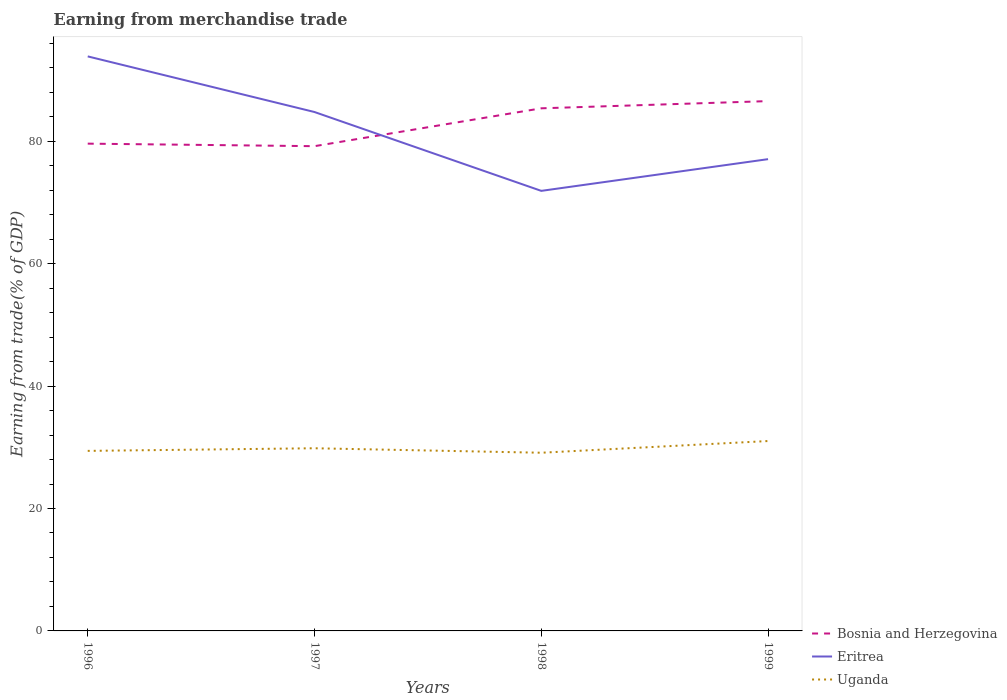How many different coloured lines are there?
Offer a very short reply. 3. Is the number of lines equal to the number of legend labels?
Offer a very short reply. Yes. Across all years, what is the maximum earnings from trade in Eritrea?
Provide a succinct answer. 71.9. What is the total earnings from trade in Bosnia and Herzegovina in the graph?
Your answer should be compact. -5.77. What is the difference between the highest and the second highest earnings from trade in Bosnia and Herzegovina?
Ensure brevity in your answer.  7.36. How many lines are there?
Your response must be concise. 3. How many years are there in the graph?
Offer a very short reply. 4. What is the difference between two consecutive major ticks on the Y-axis?
Provide a short and direct response. 20. Does the graph contain grids?
Provide a short and direct response. No. Where does the legend appear in the graph?
Make the answer very short. Bottom right. How many legend labels are there?
Make the answer very short. 3. How are the legend labels stacked?
Provide a succinct answer. Vertical. What is the title of the graph?
Your response must be concise. Earning from merchandise trade. Does "Congo (Republic)" appear as one of the legend labels in the graph?
Offer a very short reply. No. What is the label or title of the Y-axis?
Make the answer very short. Earning from trade(% of GDP). What is the Earning from trade(% of GDP) of Bosnia and Herzegovina in 1996?
Keep it short and to the point. 79.61. What is the Earning from trade(% of GDP) in Eritrea in 1996?
Offer a very short reply. 93.87. What is the Earning from trade(% of GDP) of Uganda in 1996?
Provide a short and direct response. 29.41. What is the Earning from trade(% of GDP) in Bosnia and Herzegovina in 1997?
Offer a very short reply. 79.2. What is the Earning from trade(% of GDP) of Eritrea in 1997?
Provide a short and direct response. 84.78. What is the Earning from trade(% of GDP) of Uganda in 1997?
Your answer should be compact. 29.84. What is the Earning from trade(% of GDP) of Bosnia and Herzegovina in 1998?
Keep it short and to the point. 85.38. What is the Earning from trade(% of GDP) in Eritrea in 1998?
Keep it short and to the point. 71.9. What is the Earning from trade(% of GDP) in Uganda in 1998?
Keep it short and to the point. 29.11. What is the Earning from trade(% of GDP) in Bosnia and Herzegovina in 1999?
Provide a succinct answer. 86.56. What is the Earning from trade(% of GDP) in Eritrea in 1999?
Offer a terse response. 77.08. What is the Earning from trade(% of GDP) of Uganda in 1999?
Ensure brevity in your answer.  31.02. Across all years, what is the maximum Earning from trade(% of GDP) in Bosnia and Herzegovina?
Give a very brief answer. 86.56. Across all years, what is the maximum Earning from trade(% of GDP) of Eritrea?
Keep it short and to the point. 93.87. Across all years, what is the maximum Earning from trade(% of GDP) in Uganda?
Your answer should be compact. 31.02. Across all years, what is the minimum Earning from trade(% of GDP) in Bosnia and Herzegovina?
Provide a short and direct response. 79.2. Across all years, what is the minimum Earning from trade(% of GDP) of Eritrea?
Ensure brevity in your answer.  71.9. Across all years, what is the minimum Earning from trade(% of GDP) in Uganda?
Provide a succinct answer. 29.11. What is the total Earning from trade(% of GDP) in Bosnia and Herzegovina in the graph?
Offer a very short reply. 330.75. What is the total Earning from trade(% of GDP) in Eritrea in the graph?
Give a very brief answer. 327.62. What is the total Earning from trade(% of GDP) in Uganda in the graph?
Offer a terse response. 119.39. What is the difference between the Earning from trade(% of GDP) of Bosnia and Herzegovina in 1996 and that in 1997?
Offer a very short reply. 0.41. What is the difference between the Earning from trade(% of GDP) in Eritrea in 1996 and that in 1997?
Make the answer very short. 9.09. What is the difference between the Earning from trade(% of GDP) of Uganda in 1996 and that in 1997?
Provide a succinct answer. -0.43. What is the difference between the Earning from trade(% of GDP) of Bosnia and Herzegovina in 1996 and that in 1998?
Offer a very short reply. -5.77. What is the difference between the Earning from trade(% of GDP) in Eritrea in 1996 and that in 1998?
Your answer should be very brief. 21.97. What is the difference between the Earning from trade(% of GDP) of Uganda in 1996 and that in 1998?
Provide a short and direct response. 0.3. What is the difference between the Earning from trade(% of GDP) of Bosnia and Herzegovina in 1996 and that in 1999?
Make the answer very short. -6.95. What is the difference between the Earning from trade(% of GDP) in Eritrea in 1996 and that in 1999?
Offer a terse response. 16.79. What is the difference between the Earning from trade(% of GDP) in Uganda in 1996 and that in 1999?
Offer a very short reply. -1.61. What is the difference between the Earning from trade(% of GDP) in Bosnia and Herzegovina in 1997 and that in 1998?
Provide a succinct answer. -6.19. What is the difference between the Earning from trade(% of GDP) of Eritrea in 1997 and that in 1998?
Offer a very short reply. 12.88. What is the difference between the Earning from trade(% of GDP) of Uganda in 1997 and that in 1998?
Provide a succinct answer. 0.73. What is the difference between the Earning from trade(% of GDP) in Bosnia and Herzegovina in 1997 and that in 1999?
Offer a very short reply. -7.36. What is the difference between the Earning from trade(% of GDP) in Eritrea in 1997 and that in 1999?
Keep it short and to the point. 7.7. What is the difference between the Earning from trade(% of GDP) of Uganda in 1997 and that in 1999?
Offer a terse response. -1.18. What is the difference between the Earning from trade(% of GDP) in Bosnia and Herzegovina in 1998 and that in 1999?
Your answer should be very brief. -1.18. What is the difference between the Earning from trade(% of GDP) in Eritrea in 1998 and that in 1999?
Give a very brief answer. -5.18. What is the difference between the Earning from trade(% of GDP) in Uganda in 1998 and that in 1999?
Ensure brevity in your answer.  -1.91. What is the difference between the Earning from trade(% of GDP) in Bosnia and Herzegovina in 1996 and the Earning from trade(% of GDP) in Eritrea in 1997?
Provide a succinct answer. -5.17. What is the difference between the Earning from trade(% of GDP) in Bosnia and Herzegovina in 1996 and the Earning from trade(% of GDP) in Uganda in 1997?
Make the answer very short. 49.77. What is the difference between the Earning from trade(% of GDP) in Eritrea in 1996 and the Earning from trade(% of GDP) in Uganda in 1997?
Your answer should be compact. 64.02. What is the difference between the Earning from trade(% of GDP) of Bosnia and Herzegovina in 1996 and the Earning from trade(% of GDP) of Eritrea in 1998?
Your response must be concise. 7.72. What is the difference between the Earning from trade(% of GDP) of Bosnia and Herzegovina in 1996 and the Earning from trade(% of GDP) of Uganda in 1998?
Provide a succinct answer. 50.5. What is the difference between the Earning from trade(% of GDP) in Eritrea in 1996 and the Earning from trade(% of GDP) in Uganda in 1998?
Ensure brevity in your answer.  64.75. What is the difference between the Earning from trade(% of GDP) of Bosnia and Herzegovina in 1996 and the Earning from trade(% of GDP) of Eritrea in 1999?
Your response must be concise. 2.53. What is the difference between the Earning from trade(% of GDP) in Bosnia and Herzegovina in 1996 and the Earning from trade(% of GDP) in Uganda in 1999?
Keep it short and to the point. 48.59. What is the difference between the Earning from trade(% of GDP) of Eritrea in 1996 and the Earning from trade(% of GDP) of Uganda in 1999?
Ensure brevity in your answer.  62.84. What is the difference between the Earning from trade(% of GDP) in Bosnia and Herzegovina in 1997 and the Earning from trade(% of GDP) in Eritrea in 1998?
Provide a short and direct response. 7.3. What is the difference between the Earning from trade(% of GDP) in Bosnia and Herzegovina in 1997 and the Earning from trade(% of GDP) in Uganda in 1998?
Keep it short and to the point. 50.09. What is the difference between the Earning from trade(% of GDP) in Eritrea in 1997 and the Earning from trade(% of GDP) in Uganda in 1998?
Your response must be concise. 55.67. What is the difference between the Earning from trade(% of GDP) in Bosnia and Herzegovina in 1997 and the Earning from trade(% of GDP) in Eritrea in 1999?
Make the answer very short. 2.12. What is the difference between the Earning from trade(% of GDP) in Bosnia and Herzegovina in 1997 and the Earning from trade(% of GDP) in Uganda in 1999?
Ensure brevity in your answer.  48.17. What is the difference between the Earning from trade(% of GDP) of Eritrea in 1997 and the Earning from trade(% of GDP) of Uganda in 1999?
Your response must be concise. 53.75. What is the difference between the Earning from trade(% of GDP) of Bosnia and Herzegovina in 1998 and the Earning from trade(% of GDP) of Eritrea in 1999?
Offer a very short reply. 8.31. What is the difference between the Earning from trade(% of GDP) of Bosnia and Herzegovina in 1998 and the Earning from trade(% of GDP) of Uganda in 1999?
Provide a short and direct response. 54.36. What is the difference between the Earning from trade(% of GDP) in Eritrea in 1998 and the Earning from trade(% of GDP) in Uganda in 1999?
Keep it short and to the point. 40.87. What is the average Earning from trade(% of GDP) in Bosnia and Herzegovina per year?
Ensure brevity in your answer.  82.69. What is the average Earning from trade(% of GDP) in Eritrea per year?
Your response must be concise. 81.9. What is the average Earning from trade(% of GDP) in Uganda per year?
Your answer should be compact. 29.85. In the year 1996, what is the difference between the Earning from trade(% of GDP) in Bosnia and Herzegovina and Earning from trade(% of GDP) in Eritrea?
Your answer should be very brief. -14.26. In the year 1996, what is the difference between the Earning from trade(% of GDP) of Bosnia and Herzegovina and Earning from trade(% of GDP) of Uganda?
Provide a short and direct response. 50.2. In the year 1996, what is the difference between the Earning from trade(% of GDP) in Eritrea and Earning from trade(% of GDP) in Uganda?
Provide a succinct answer. 64.45. In the year 1997, what is the difference between the Earning from trade(% of GDP) of Bosnia and Herzegovina and Earning from trade(% of GDP) of Eritrea?
Your answer should be compact. -5.58. In the year 1997, what is the difference between the Earning from trade(% of GDP) in Bosnia and Herzegovina and Earning from trade(% of GDP) in Uganda?
Ensure brevity in your answer.  49.35. In the year 1997, what is the difference between the Earning from trade(% of GDP) in Eritrea and Earning from trade(% of GDP) in Uganda?
Your response must be concise. 54.93. In the year 1998, what is the difference between the Earning from trade(% of GDP) in Bosnia and Herzegovina and Earning from trade(% of GDP) in Eritrea?
Ensure brevity in your answer.  13.49. In the year 1998, what is the difference between the Earning from trade(% of GDP) in Bosnia and Herzegovina and Earning from trade(% of GDP) in Uganda?
Offer a very short reply. 56.27. In the year 1998, what is the difference between the Earning from trade(% of GDP) in Eritrea and Earning from trade(% of GDP) in Uganda?
Keep it short and to the point. 42.78. In the year 1999, what is the difference between the Earning from trade(% of GDP) in Bosnia and Herzegovina and Earning from trade(% of GDP) in Eritrea?
Your answer should be compact. 9.48. In the year 1999, what is the difference between the Earning from trade(% of GDP) of Bosnia and Herzegovina and Earning from trade(% of GDP) of Uganda?
Make the answer very short. 55.54. In the year 1999, what is the difference between the Earning from trade(% of GDP) of Eritrea and Earning from trade(% of GDP) of Uganda?
Your answer should be very brief. 46.05. What is the ratio of the Earning from trade(% of GDP) of Eritrea in 1996 to that in 1997?
Make the answer very short. 1.11. What is the ratio of the Earning from trade(% of GDP) in Uganda in 1996 to that in 1997?
Provide a succinct answer. 0.99. What is the ratio of the Earning from trade(% of GDP) in Bosnia and Herzegovina in 1996 to that in 1998?
Your response must be concise. 0.93. What is the ratio of the Earning from trade(% of GDP) in Eritrea in 1996 to that in 1998?
Give a very brief answer. 1.31. What is the ratio of the Earning from trade(% of GDP) in Uganda in 1996 to that in 1998?
Make the answer very short. 1.01. What is the ratio of the Earning from trade(% of GDP) of Bosnia and Herzegovina in 1996 to that in 1999?
Offer a terse response. 0.92. What is the ratio of the Earning from trade(% of GDP) of Eritrea in 1996 to that in 1999?
Make the answer very short. 1.22. What is the ratio of the Earning from trade(% of GDP) of Uganda in 1996 to that in 1999?
Keep it short and to the point. 0.95. What is the ratio of the Earning from trade(% of GDP) of Bosnia and Herzegovina in 1997 to that in 1998?
Provide a short and direct response. 0.93. What is the ratio of the Earning from trade(% of GDP) of Eritrea in 1997 to that in 1998?
Offer a very short reply. 1.18. What is the ratio of the Earning from trade(% of GDP) of Uganda in 1997 to that in 1998?
Your response must be concise. 1.03. What is the ratio of the Earning from trade(% of GDP) in Bosnia and Herzegovina in 1997 to that in 1999?
Provide a short and direct response. 0.91. What is the ratio of the Earning from trade(% of GDP) of Eritrea in 1997 to that in 1999?
Ensure brevity in your answer.  1.1. What is the ratio of the Earning from trade(% of GDP) of Bosnia and Herzegovina in 1998 to that in 1999?
Offer a terse response. 0.99. What is the ratio of the Earning from trade(% of GDP) in Eritrea in 1998 to that in 1999?
Your answer should be compact. 0.93. What is the ratio of the Earning from trade(% of GDP) in Uganda in 1998 to that in 1999?
Your answer should be compact. 0.94. What is the difference between the highest and the second highest Earning from trade(% of GDP) of Bosnia and Herzegovina?
Your response must be concise. 1.18. What is the difference between the highest and the second highest Earning from trade(% of GDP) of Eritrea?
Your answer should be very brief. 9.09. What is the difference between the highest and the second highest Earning from trade(% of GDP) in Uganda?
Your answer should be compact. 1.18. What is the difference between the highest and the lowest Earning from trade(% of GDP) of Bosnia and Herzegovina?
Your answer should be very brief. 7.36. What is the difference between the highest and the lowest Earning from trade(% of GDP) of Eritrea?
Give a very brief answer. 21.97. What is the difference between the highest and the lowest Earning from trade(% of GDP) in Uganda?
Make the answer very short. 1.91. 